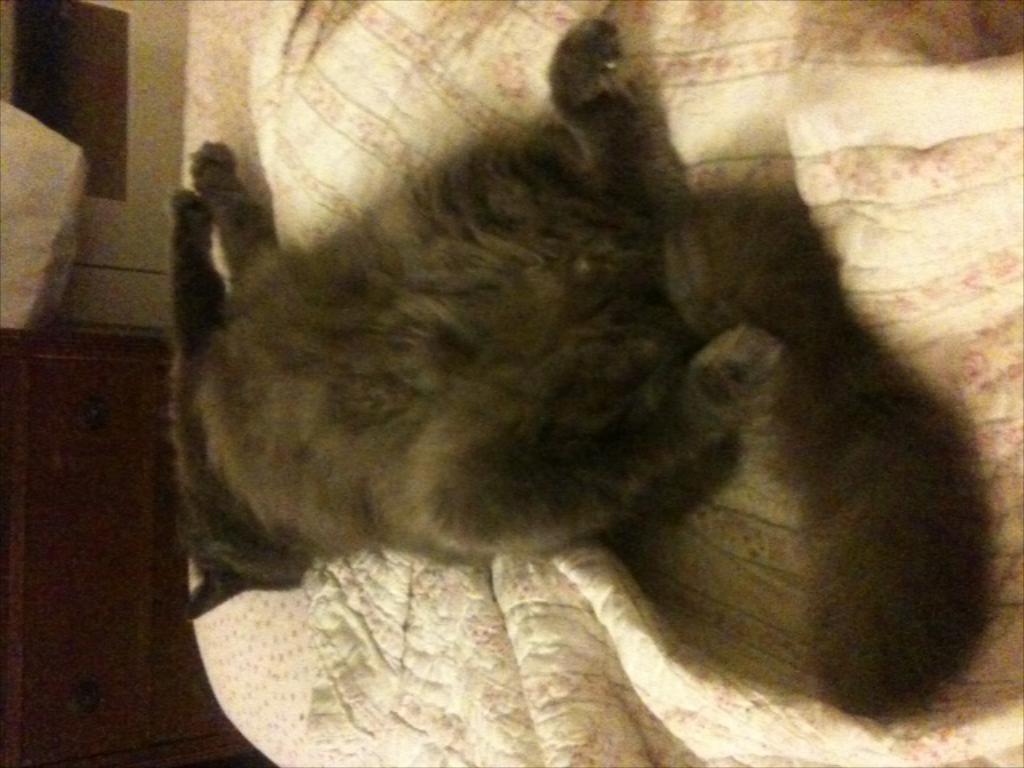Please provide a concise description of this image. In this picture we can see an animal is lying, at the bottom there is a bed sheet, it looks like a cupboard in the background. 